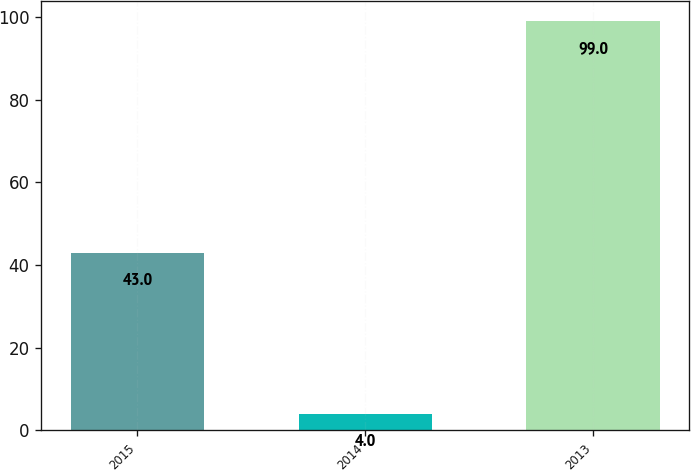Convert chart to OTSL. <chart><loc_0><loc_0><loc_500><loc_500><bar_chart><fcel>2015<fcel>2014<fcel>2013<nl><fcel>43<fcel>4<fcel>99<nl></chart> 